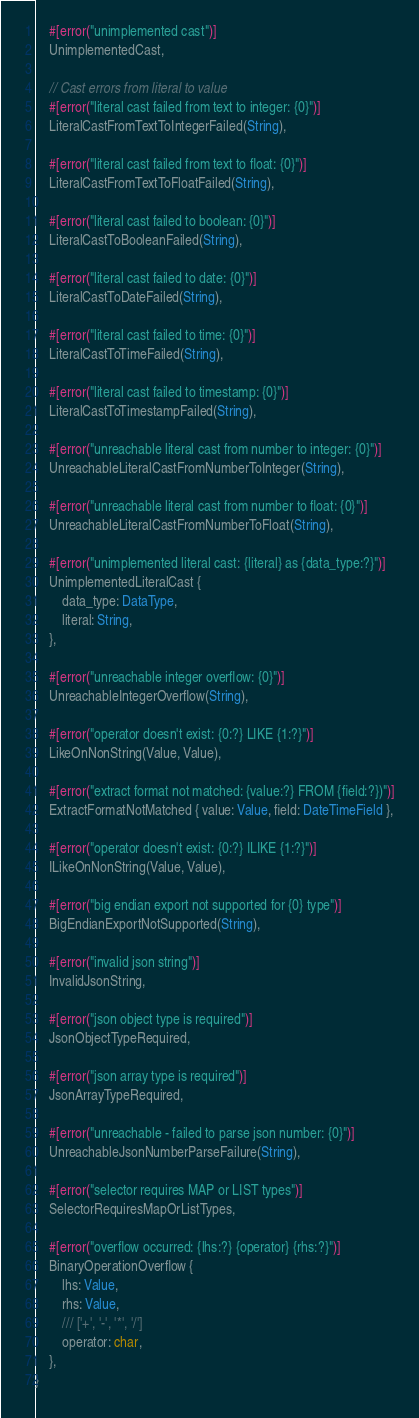<code> <loc_0><loc_0><loc_500><loc_500><_Rust_>    #[error("unimplemented cast")]
    UnimplementedCast,

    // Cast errors from literal to value
    #[error("literal cast failed from text to integer: {0}")]
    LiteralCastFromTextToIntegerFailed(String),

    #[error("literal cast failed from text to float: {0}")]
    LiteralCastFromTextToFloatFailed(String),

    #[error("literal cast failed to boolean: {0}")]
    LiteralCastToBooleanFailed(String),

    #[error("literal cast failed to date: {0}")]
    LiteralCastToDateFailed(String),

    #[error("literal cast failed to time: {0}")]
    LiteralCastToTimeFailed(String),

    #[error("literal cast failed to timestamp: {0}")]
    LiteralCastToTimestampFailed(String),

    #[error("unreachable literal cast from number to integer: {0}")]
    UnreachableLiteralCastFromNumberToInteger(String),

    #[error("unreachable literal cast from number to float: {0}")]
    UnreachableLiteralCastFromNumberToFloat(String),

    #[error("unimplemented literal cast: {literal} as {data_type:?}")]
    UnimplementedLiteralCast {
        data_type: DataType,
        literal: String,
    },

    #[error("unreachable integer overflow: {0}")]
    UnreachableIntegerOverflow(String),

    #[error("operator doesn't exist: {0:?} LIKE {1:?}")]
    LikeOnNonString(Value, Value),

    #[error("extract format not matched: {value:?} FROM {field:?})")]
    ExtractFormatNotMatched { value: Value, field: DateTimeField },

    #[error("operator doesn't exist: {0:?} ILIKE {1:?}")]
    ILikeOnNonString(Value, Value),

    #[error("big endian export not supported for {0} type")]
    BigEndianExportNotSupported(String),

    #[error("invalid json string")]
    InvalidJsonString,

    #[error("json object type is required")]
    JsonObjectTypeRequired,

    #[error("json array type is required")]
    JsonArrayTypeRequired,

    #[error("unreachable - failed to parse json number: {0}")]
    UnreachableJsonNumberParseFailure(String),

    #[error("selector requires MAP or LIST types")]
    SelectorRequiresMapOrListTypes,

    #[error("overflow occurred: {lhs:?} {operator} {rhs:?}")]
    BinaryOperationOverflow {
        lhs: Value,
        rhs: Value,
        /// ['+', '-', '*', '/']
        operator: char,
    },
}
</code> 